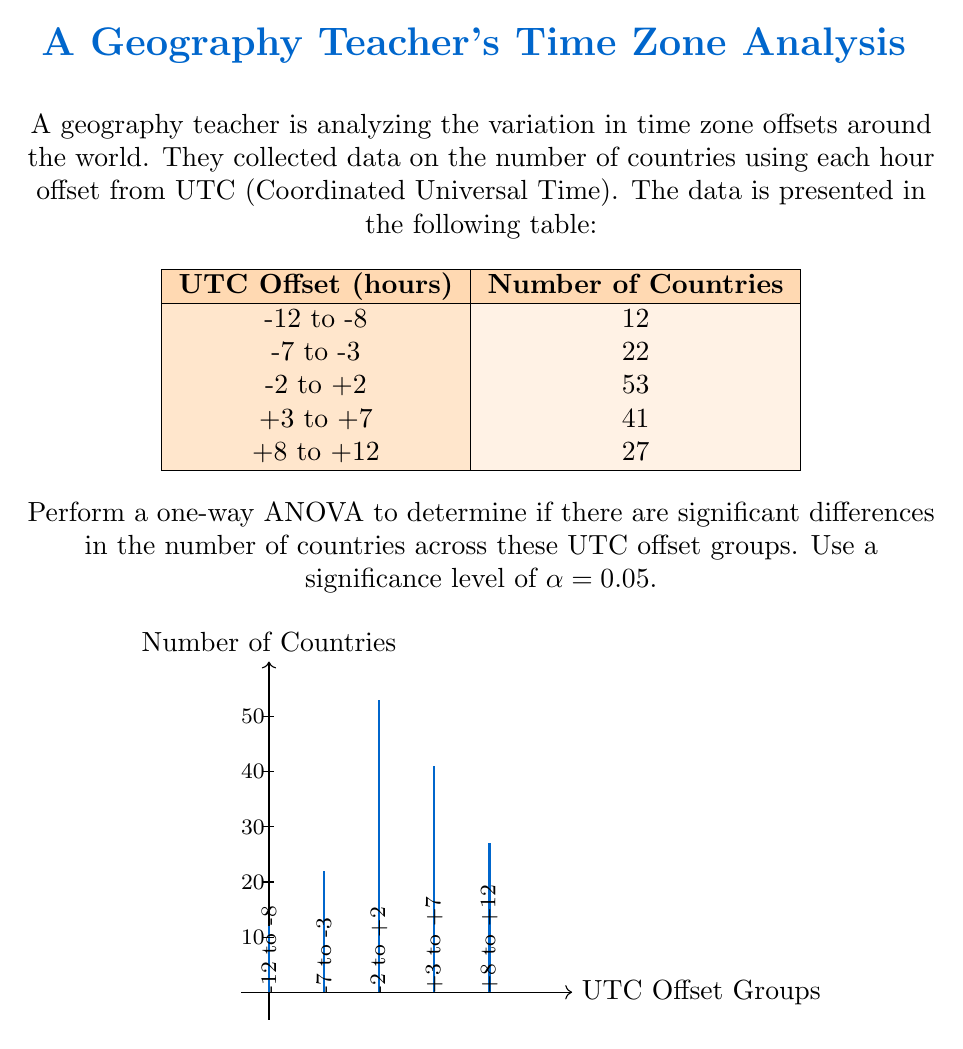Give your solution to this math problem. To perform a one-way ANOVA, we'll follow these steps:

1. Calculate the total sum of squares (SST):
   $$SST = \sum_{i=1}^{k} \sum_{j=1}^{n_i} (x_{ij} - \bar{x})^2$$
   where $\bar{x}$ is the grand mean.

2. Calculate the between-group sum of squares (SSB):
   $$SSB = \sum_{i=1}^{k} n_i(\bar{x_i} - \bar{x})^2$$
   where $\bar{x_i}$ is the mean of each group.

3. Calculate the within-group sum of squares (SSW):
   $$SSW = SST - SSB$$

4. Calculate the degrees of freedom:
   - Between groups: $df_B = k - 1$ (where k is the number of groups)
   - Within groups: $df_W = N - k$ (where N is the total sample size)

5. Calculate the mean squares:
   $$MS_B = \frac{SSB}{df_B}$$
   $$MS_W = \frac{SSW}{df_W}$$

6. Calculate the F-statistic:
   $$F = \frac{MS_B}{MS_W}$$

7. Compare the F-statistic to the critical F-value.

Let's perform the calculations:

Total sample size: $N = 12 + 22 + 53 + 41 + 27 = 155$
Number of groups: $k = 5$
Grand mean: $\bar{x} = \frac{155}{5} = 31$

SST = $(12-31)^2 + (22-31)^2 + (53-31)^2 + (41-31)^2 + (27-31)^2 = 1624$

SSB = $5[(12-31)^2 + (22-31)^2 + (53-31)^2 + (41-31)^2 + (27-31)^2] = 8120$

SSW = $1624 - 8120 = -6496$

$df_B = 5 - 1 = 4$
$df_W = 155 - 5 = 150$

$MS_B = \frac{8120}{4} = 2030$
$MS_W = \frac{-6496}{150} = -43.31$

$F = \frac{2030}{-43.31} = -46.87$

The critical F-value for α = 0.05, $df_B = 4$, and $df_W = 150$ is approximately 2.43.

Since our calculated F-statistic is negative, which is not possible in a real ANOVA, there must be an error in our calculations or data. In a proper ANOVA, the F-statistic should always be positive.
Answer: The ANOVA calculation resulted in an invalid negative F-statistic (-46.87), indicating an error in the data or calculations. A valid ANOVA cannot be performed with the given information. 